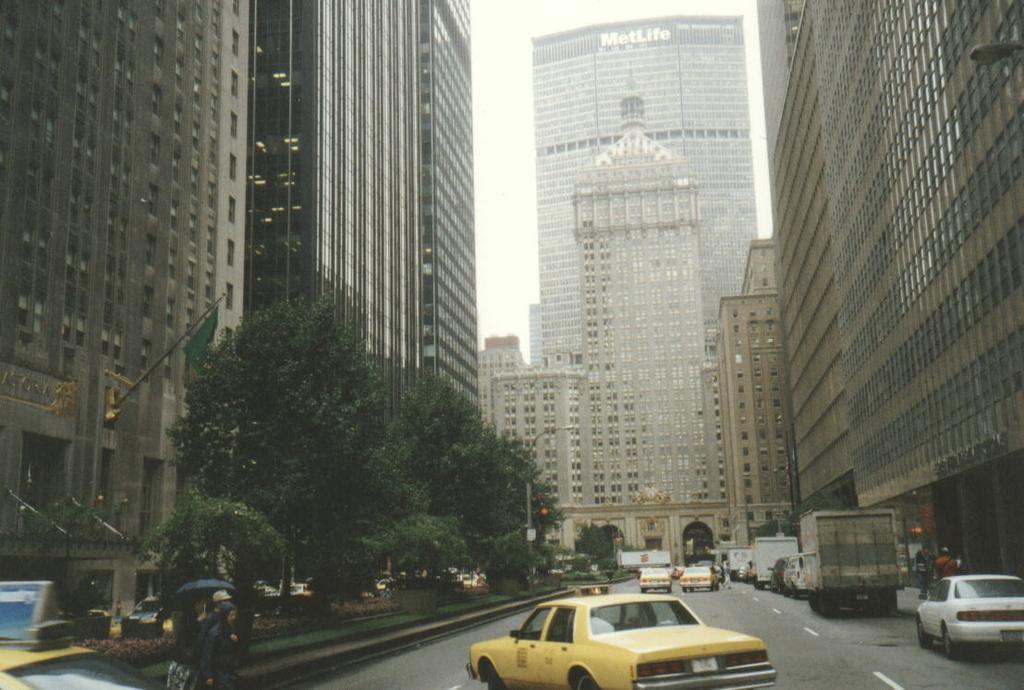<image>
Share a concise interpretation of the image provided. a taxi can in New York with a sign at the top of it and a Metlife building 